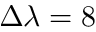Convert formula to latex. <formula><loc_0><loc_0><loc_500><loc_500>\Delta \lambda = 8</formula> 